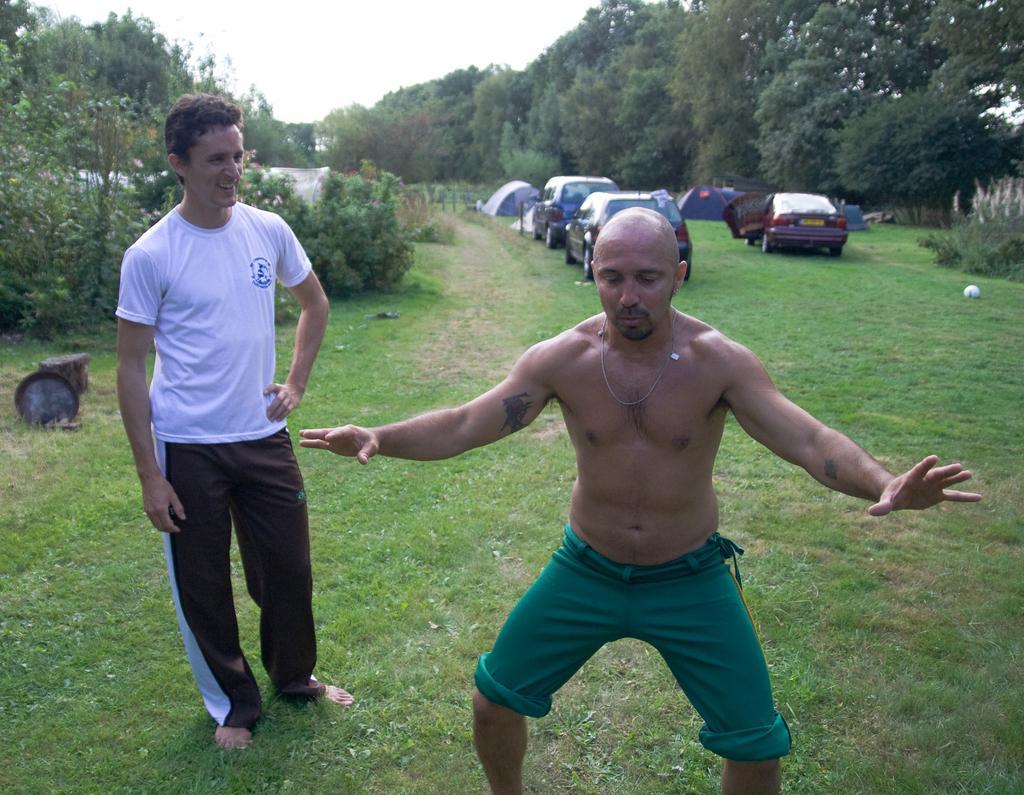Can you describe this image briefly? In this image we can see men standing on the ground, motor vehicles on the ground, bushes, trees and sky. 